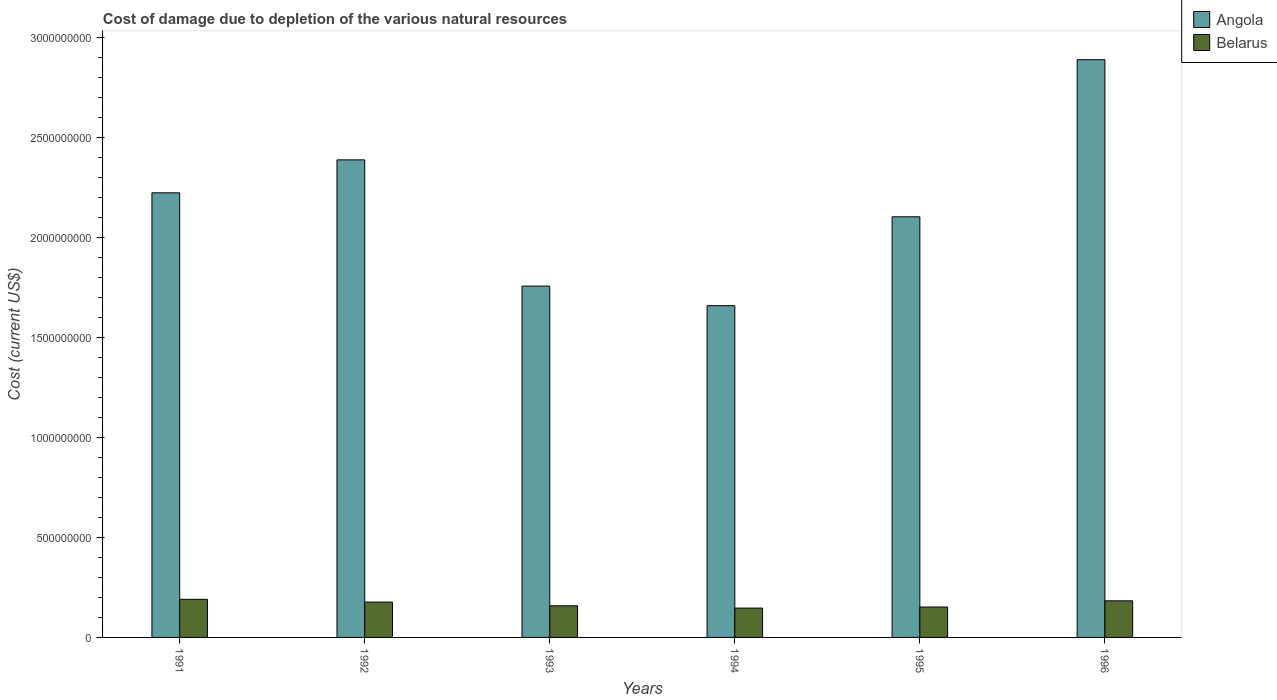How many groups of bars are there?
Make the answer very short. 6. Are the number of bars per tick equal to the number of legend labels?
Provide a succinct answer. Yes. Are the number of bars on each tick of the X-axis equal?
Make the answer very short. Yes. How many bars are there on the 1st tick from the right?
Offer a very short reply. 2. What is the cost of damage caused due to the depletion of various natural resources in Angola in 1996?
Keep it short and to the point. 2.89e+09. Across all years, what is the maximum cost of damage caused due to the depletion of various natural resources in Angola?
Make the answer very short. 2.89e+09. Across all years, what is the minimum cost of damage caused due to the depletion of various natural resources in Belarus?
Your answer should be very brief. 1.47e+08. In which year was the cost of damage caused due to the depletion of various natural resources in Belarus maximum?
Your answer should be very brief. 1991. In which year was the cost of damage caused due to the depletion of various natural resources in Belarus minimum?
Offer a terse response. 1994. What is the total cost of damage caused due to the depletion of various natural resources in Belarus in the graph?
Provide a succinct answer. 1.01e+09. What is the difference between the cost of damage caused due to the depletion of various natural resources in Angola in 1991 and that in 1992?
Ensure brevity in your answer.  -1.65e+08. What is the difference between the cost of damage caused due to the depletion of various natural resources in Angola in 1991 and the cost of damage caused due to the depletion of various natural resources in Belarus in 1996?
Offer a very short reply. 2.04e+09. What is the average cost of damage caused due to the depletion of various natural resources in Angola per year?
Your answer should be very brief. 2.17e+09. In the year 1995, what is the difference between the cost of damage caused due to the depletion of various natural resources in Angola and cost of damage caused due to the depletion of various natural resources in Belarus?
Your answer should be compact. 1.95e+09. In how many years, is the cost of damage caused due to the depletion of various natural resources in Belarus greater than 2200000000 US$?
Give a very brief answer. 0. What is the ratio of the cost of damage caused due to the depletion of various natural resources in Belarus in 1991 to that in 1992?
Ensure brevity in your answer.  1.08. Is the cost of damage caused due to the depletion of various natural resources in Belarus in 1991 less than that in 1995?
Make the answer very short. No. What is the difference between the highest and the second highest cost of damage caused due to the depletion of various natural resources in Angola?
Your response must be concise. 5.01e+08. What is the difference between the highest and the lowest cost of damage caused due to the depletion of various natural resources in Angola?
Give a very brief answer. 1.23e+09. What does the 1st bar from the left in 1996 represents?
Provide a short and direct response. Angola. What does the 1st bar from the right in 1995 represents?
Provide a succinct answer. Belarus. How many bars are there?
Ensure brevity in your answer.  12. Are all the bars in the graph horizontal?
Make the answer very short. No. What is the difference between two consecutive major ticks on the Y-axis?
Your answer should be compact. 5.00e+08. Are the values on the major ticks of Y-axis written in scientific E-notation?
Offer a terse response. No. Does the graph contain any zero values?
Provide a succinct answer. No. Does the graph contain grids?
Keep it short and to the point. No. How are the legend labels stacked?
Give a very brief answer. Vertical. What is the title of the graph?
Make the answer very short. Cost of damage due to depletion of the various natural resources. Does "Comoros" appear as one of the legend labels in the graph?
Provide a succinct answer. No. What is the label or title of the X-axis?
Provide a succinct answer. Years. What is the label or title of the Y-axis?
Offer a terse response. Cost (current US$). What is the Cost (current US$) of Angola in 1991?
Ensure brevity in your answer.  2.22e+09. What is the Cost (current US$) in Belarus in 1991?
Your answer should be very brief. 1.91e+08. What is the Cost (current US$) of Angola in 1992?
Offer a very short reply. 2.39e+09. What is the Cost (current US$) of Belarus in 1992?
Offer a terse response. 1.77e+08. What is the Cost (current US$) in Angola in 1993?
Give a very brief answer. 1.76e+09. What is the Cost (current US$) in Belarus in 1993?
Provide a short and direct response. 1.58e+08. What is the Cost (current US$) in Angola in 1994?
Offer a terse response. 1.66e+09. What is the Cost (current US$) in Belarus in 1994?
Offer a terse response. 1.47e+08. What is the Cost (current US$) in Angola in 1995?
Provide a short and direct response. 2.10e+09. What is the Cost (current US$) in Belarus in 1995?
Provide a succinct answer. 1.52e+08. What is the Cost (current US$) of Angola in 1996?
Your response must be concise. 2.89e+09. What is the Cost (current US$) in Belarus in 1996?
Ensure brevity in your answer.  1.83e+08. Across all years, what is the maximum Cost (current US$) of Angola?
Your answer should be very brief. 2.89e+09. Across all years, what is the maximum Cost (current US$) of Belarus?
Your answer should be compact. 1.91e+08. Across all years, what is the minimum Cost (current US$) of Angola?
Your response must be concise. 1.66e+09. Across all years, what is the minimum Cost (current US$) in Belarus?
Provide a short and direct response. 1.47e+08. What is the total Cost (current US$) in Angola in the graph?
Offer a very short reply. 1.30e+1. What is the total Cost (current US$) in Belarus in the graph?
Give a very brief answer. 1.01e+09. What is the difference between the Cost (current US$) of Angola in 1991 and that in 1992?
Provide a succinct answer. -1.65e+08. What is the difference between the Cost (current US$) of Belarus in 1991 and that in 1992?
Ensure brevity in your answer.  1.37e+07. What is the difference between the Cost (current US$) in Angola in 1991 and that in 1993?
Your response must be concise. 4.66e+08. What is the difference between the Cost (current US$) in Belarus in 1991 and that in 1993?
Keep it short and to the point. 3.23e+07. What is the difference between the Cost (current US$) in Angola in 1991 and that in 1994?
Make the answer very short. 5.64e+08. What is the difference between the Cost (current US$) of Belarus in 1991 and that in 1994?
Keep it short and to the point. 4.38e+07. What is the difference between the Cost (current US$) in Angola in 1991 and that in 1995?
Offer a very short reply. 1.20e+08. What is the difference between the Cost (current US$) of Belarus in 1991 and that in 1995?
Keep it short and to the point. 3.85e+07. What is the difference between the Cost (current US$) in Angola in 1991 and that in 1996?
Ensure brevity in your answer.  -6.66e+08. What is the difference between the Cost (current US$) in Belarus in 1991 and that in 1996?
Offer a terse response. 7.45e+06. What is the difference between the Cost (current US$) of Angola in 1992 and that in 1993?
Your answer should be very brief. 6.31e+08. What is the difference between the Cost (current US$) in Belarus in 1992 and that in 1993?
Your response must be concise. 1.86e+07. What is the difference between the Cost (current US$) of Angola in 1992 and that in 1994?
Offer a very short reply. 7.29e+08. What is the difference between the Cost (current US$) in Belarus in 1992 and that in 1994?
Give a very brief answer. 3.01e+07. What is the difference between the Cost (current US$) in Angola in 1992 and that in 1995?
Offer a terse response. 2.85e+08. What is the difference between the Cost (current US$) in Belarus in 1992 and that in 1995?
Provide a succinct answer. 2.48e+07. What is the difference between the Cost (current US$) in Angola in 1992 and that in 1996?
Your answer should be very brief. -5.01e+08. What is the difference between the Cost (current US$) in Belarus in 1992 and that in 1996?
Your answer should be very brief. -6.24e+06. What is the difference between the Cost (current US$) in Angola in 1993 and that in 1994?
Provide a short and direct response. 9.80e+07. What is the difference between the Cost (current US$) of Belarus in 1993 and that in 1994?
Provide a succinct answer. 1.15e+07. What is the difference between the Cost (current US$) in Angola in 1993 and that in 1995?
Keep it short and to the point. -3.47e+08. What is the difference between the Cost (current US$) in Belarus in 1993 and that in 1995?
Your answer should be compact. 6.13e+06. What is the difference between the Cost (current US$) of Angola in 1993 and that in 1996?
Your response must be concise. -1.13e+09. What is the difference between the Cost (current US$) in Belarus in 1993 and that in 1996?
Make the answer very short. -2.49e+07. What is the difference between the Cost (current US$) of Angola in 1994 and that in 1995?
Offer a very short reply. -4.45e+08. What is the difference between the Cost (current US$) in Belarus in 1994 and that in 1995?
Your response must be concise. -5.32e+06. What is the difference between the Cost (current US$) of Angola in 1994 and that in 1996?
Make the answer very short. -1.23e+09. What is the difference between the Cost (current US$) in Belarus in 1994 and that in 1996?
Ensure brevity in your answer.  -3.63e+07. What is the difference between the Cost (current US$) of Angola in 1995 and that in 1996?
Ensure brevity in your answer.  -7.86e+08. What is the difference between the Cost (current US$) in Belarus in 1995 and that in 1996?
Offer a terse response. -3.10e+07. What is the difference between the Cost (current US$) of Angola in 1991 and the Cost (current US$) of Belarus in 1992?
Keep it short and to the point. 2.05e+09. What is the difference between the Cost (current US$) of Angola in 1991 and the Cost (current US$) of Belarus in 1993?
Your answer should be very brief. 2.07e+09. What is the difference between the Cost (current US$) of Angola in 1991 and the Cost (current US$) of Belarus in 1994?
Your response must be concise. 2.08e+09. What is the difference between the Cost (current US$) of Angola in 1991 and the Cost (current US$) of Belarus in 1995?
Give a very brief answer. 2.07e+09. What is the difference between the Cost (current US$) in Angola in 1991 and the Cost (current US$) in Belarus in 1996?
Keep it short and to the point. 2.04e+09. What is the difference between the Cost (current US$) in Angola in 1992 and the Cost (current US$) in Belarus in 1993?
Provide a succinct answer. 2.23e+09. What is the difference between the Cost (current US$) of Angola in 1992 and the Cost (current US$) of Belarus in 1994?
Give a very brief answer. 2.24e+09. What is the difference between the Cost (current US$) in Angola in 1992 and the Cost (current US$) in Belarus in 1995?
Provide a succinct answer. 2.24e+09. What is the difference between the Cost (current US$) in Angola in 1992 and the Cost (current US$) in Belarus in 1996?
Ensure brevity in your answer.  2.21e+09. What is the difference between the Cost (current US$) in Angola in 1993 and the Cost (current US$) in Belarus in 1994?
Provide a short and direct response. 1.61e+09. What is the difference between the Cost (current US$) in Angola in 1993 and the Cost (current US$) in Belarus in 1995?
Offer a terse response. 1.61e+09. What is the difference between the Cost (current US$) of Angola in 1993 and the Cost (current US$) of Belarus in 1996?
Give a very brief answer. 1.57e+09. What is the difference between the Cost (current US$) in Angola in 1994 and the Cost (current US$) in Belarus in 1995?
Provide a short and direct response. 1.51e+09. What is the difference between the Cost (current US$) in Angola in 1994 and the Cost (current US$) in Belarus in 1996?
Ensure brevity in your answer.  1.48e+09. What is the difference between the Cost (current US$) of Angola in 1995 and the Cost (current US$) of Belarus in 1996?
Your answer should be very brief. 1.92e+09. What is the average Cost (current US$) of Angola per year?
Offer a very short reply. 2.17e+09. What is the average Cost (current US$) of Belarus per year?
Your answer should be very brief. 1.68e+08. In the year 1991, what is the difference between the Cost (current US$) in Angola and Cost (current US$) in Belarus?
Provide a short and direct response. 2.03e+09. In the year 1992, what is the difference between the Cost (current US$) of Angola and Cost (current US$) of Belarus?
Your response must be concise. 2.21e+09. In the year 1993, what is the difference between the Cost (current US$) in Angola and Cost (current US$) in Belarus?
Your response must be concise. 1.60e+09. In the year 1994, what is the difference between the Cost (current US$) of Angola and Cost (current US$) of Belarus?
Provide a short and direct response. 1.51e+09. In the year 1995, what is the difference between the Cost (current US$) of Angola and Cost (current US$) of Belarus?
Your answer should be compact. 1.95e+09. In the year 1996, what is the difference between the Cost (current US$) in Angola and Cost (current US$) in Belarus?
Your response must be concise. 2.71e+09. What is the ratio of the Cost (current US$) of Belarus in 1991 to that in 1992?
Offer a terse response. 1.08. What is the ratio of the Cost (current US$) in Angola in 1991 to that in 1993?
Give a very brief answer. 1.27. What is the ratio of the Cost (current US$) of Belarus in 1991 to that in 1993?
Ensure brevity in your answer.  1.2. What is the ratio of the Cost (current US$) of Angola in 1991 to that in 1994?
Offer a very short reply. 1.34. What is the ratio of the Cost (current US$) in Belarus in 1991 to that in 1994?
Provide a short and direct response. 1.3. What is the ratio of the Cost (current US$) of Angola in 1991 to that in 1995?
Your answer should be very brief. 1.06. What is the ratio of the Cost (current US$) of Belarus in 1991 to that in 1995?
Provide a short and direct response. 1.25. What is the ratio of the Cost (current US$) in Angola in 1991 to that in 1996?
Your answer should be compact. 0.77. What is the ratio of the Cost (current US$) of Belarus in 1991 to that in 1996?
Provide a succinct answer. 1.04. What is the ratio of the Cost (current US$) in Angola in 1992 to that in 1993?
Provide a short and direct response. 1.36. What is the ratio of the Cost (current US$) in Belarus in 1992 to that in 1993?
Offer a very short reply. 1.12. What is the ratio of the Cost (current US$) of Angola in 1992 to that in 1994?
Ensure brevity in your answer.  1.44. What is the ratio of the Cost (current US$) of Belarus in 1992 to that in 1994?
Provide a short and direct response. 1.21. What is the ratio of the Cost (current US$) in Angola in 1992 to that in 1995?
Offer a very short reply. 1.14. What is the ratio of the Cost (current US$) of Belarus in 1992 to that in 1995?
Provide a short and direct response. 1.16. What is the ratio of the Cost (current US$) in Angola in 1992 to that in 1996?
Your response must be concise. 0.83. What is the ratio of the Cost (current US$) in Belarus in 1992 to that in 1996?
Ensure brevity in your answer.  0.97. What is the ratio of the Cost (current US$) in Angola in 1993 to that in 1994?
Give a very brief answer. 1.06. What is the ratio of the Cost (current US$) of Belarus in 1993 to that in 1994?
Give a very brief answer. 1.08. What is the ratio of the Cost (current US$) in Angola in 1993 to that in 1995?
Give a very brief answer. 0.84. What is the ratio of the Cost (current US$) of Belarus in 1993 to that in 1995?
Your answer should be very brief. 1.04. What is the ratio of the Cost (current US$) of Angola in 1993 to that in 1996?
Your response must be concise. 0.61. What is the ratio of the Cost (current US$) in Belarus in 1993 to that in 1996?
Provide a succinct answer. 0.86. What is the ratio of the Cost (current US$) of Angola in 1994 to that in 1995?
Make the answer very short. 0.79. What is the ratio of the Cost (current US$) of Angola in 1994 to that in 1996?
Offer a terse response. 0.57. What is the ratio of the Cost (current US$) of Belarus in 1994 to that in 1996?
Keep it short and to the point. 0.8. What is the ratio of the Cost (current US$) in Angola in 1995 to that in 1996?
Keep it short and to the point. 0.73. What is the ratio of the Cost (current US$) in Belarus in 1995 to that in 1996?
Give a very brief answer. 0.83. What is the difference between the highest and the second highest Cost (current US$) in Angola?
Your answer should be compact. 5.01e+08. What is the difference between the highest and the second highest Cost (current US$) in Belarus?
Your response must be concise. 7.45e+06. What is the difference between the highest and the lowest Cost (current US$) in Angola?
Your response must be concise. 1.23e+09. What is the difference between the highest and the lowest Cost (current US$) in Belarus?
Make the answer very short. 4.38e+07. 